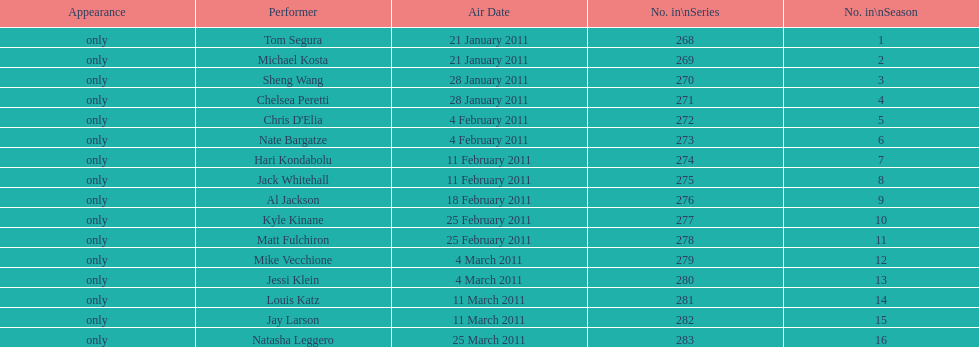Did al jackson air before or after kyle kinane? Before. 